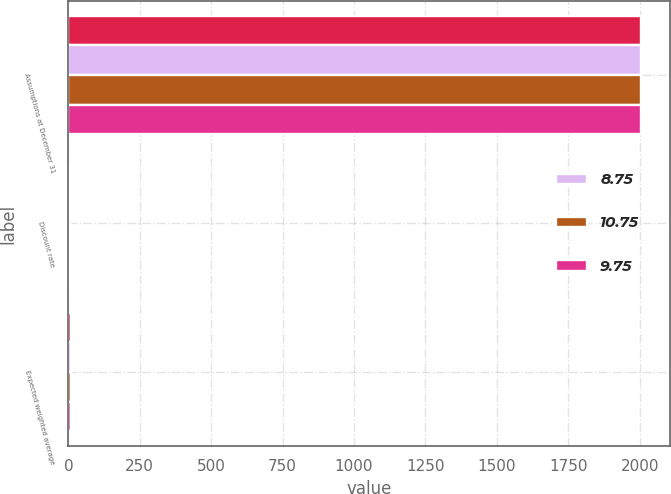<chart> <loc_0><loc_0><loc_500><loc_500><stacked_bar_chart><ecel><fcel>Assumptions at December 31<fcel>Discount rate<fcel>Expected weighted average<nl><fcel>nan<fcel>2005<fcel>5.7<fcel>8.15<nl><fcel>8.75<fcel>2005<fcel>5.74<fcel>8<nl><fcel>10.75<fcel>2004<fcel>6<fcel>8<nl><fcel>9.75<fcel>2003<fcel>6.25<fcel>8<nl></chart> 